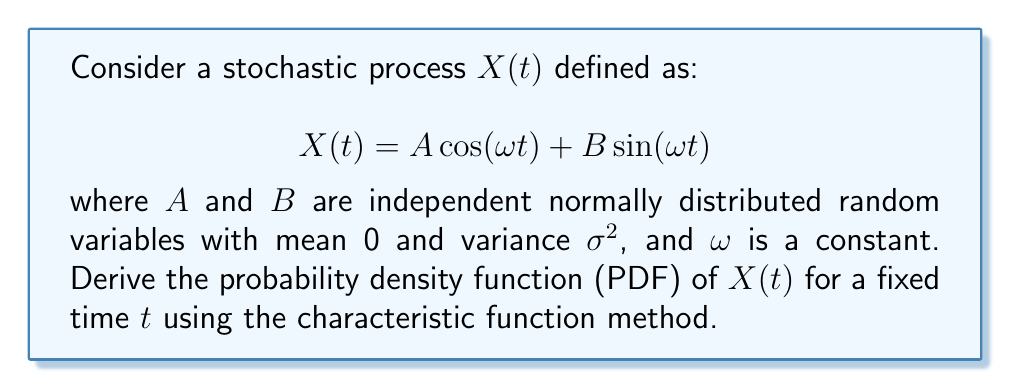Solve this math problem. To solve this problem, we'll follow these steps:

1) First, we need to find the characteristic function of $X(t)$.

2) The characteristic function of $X(t)$ is defined as:

   $$\phi_{X(t)}(u) = E[e^{iuX(t)}]$$

3) Substituting the expression for $X(t)$:

   $$\phi_{X(t)}(u) = E[e^{iu(A \cos(\omega t) + B \sin(\omega t))}]$$

4) Using the independence of $A$ and $B$, we can separate this expectation:

   $$\phi_{X(t)}(u) = E[e^{iuA \cos(\omega t)}] \cdot E[e^{iuB \sin(\omega t)}]$$

5) For a normally distributed random variable $Y$ with mean $\mu$ and variance $\sigma^2$, its characteristic function is:

   $$\phi_Y(u) = e^{iu\mu - \frac{1}{2}u^2\sigma^2}$$

6) Applying this to our case, where both $A$ and $B$ have mean 0 and variance $\sigma^2$:

   $$\phi_{X(t)}(u) = e^{-\frac{1}{2}u^2\sigma^2\cos^2(\omega t)} \cdot e^{-\frac{1}{2}u^2\sigma^2\sin^2(\omega t)}$$

7) Simplifying:

   $$\phi_{X(t)}(u) = e^{-\frac{1}{2}u^2\sigma^2(\cos^2(\omega t) + \sin^2(\omega t))} = e^{-\frac{1}{2}u^2\sigma^2}$$

8) This is the characteristic function of a normal distribution with mean 0 and variance $\sigma^2$.

9) Therefore, $X(t)$ follows a normal distribution with mean 0 and variance $\sigma^2$ for any fixed $t$.

10) The probability density function (PDF) of a normal distribution with mean $\mu$ and variance $\sigma^2$ is:

    $$f(x) = \frac{1}{\sigma\sqrt{2\pi}} e^{-\frac{(x-\mu)^2}{2\sigma^2}}$$

11) In our case, $\mu = 0$, so the PDF of $X(t)$ is:

    $$f_{X(t)}(x) = \frac{1}{\sigma\sqrt{2\pi}} e^{-\frac{x^2}{2\sigma^2}}$$
Answer: The probability density function of $X(t)$ for a fixed time $t$ is:

$$f_{X(t)}(x) = \frac{1}{\sigma\sqrt{2\pi}} e^{-\frac{x^2}{2\sigma^2}}$$

which is a normal distribution with mean 0 and variance $\sigma^2$. 